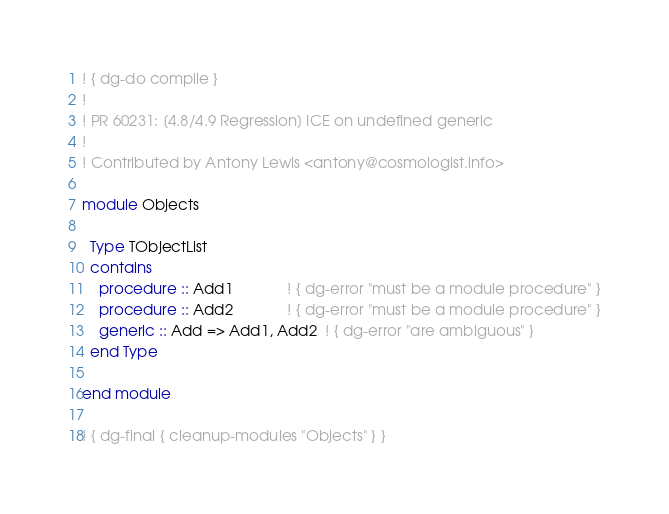Convert code to text. <code><loc_0><loc_0><loc_500><loc_500><_FORTRAN_>! { dg-do compile }
!
! PR 60231: [4.8/4.9 Regression] ICE on undefined generic
!
! Contributed by Antony Lewis <antony@cosmologist.info>

module Objects

  Type TObjectList
  contains
    procedure :: Add1             ! { dg-error "must be a module procedure" }
    procedure :: Add2             ! { dg-error "must be a module procedure" }
    generic :: Add => Add1, Add2  ! { dg-error "are ambiguous" }
  end Type

end module

! { dg-final { cleanup-modules "Objects" } }
</code> 